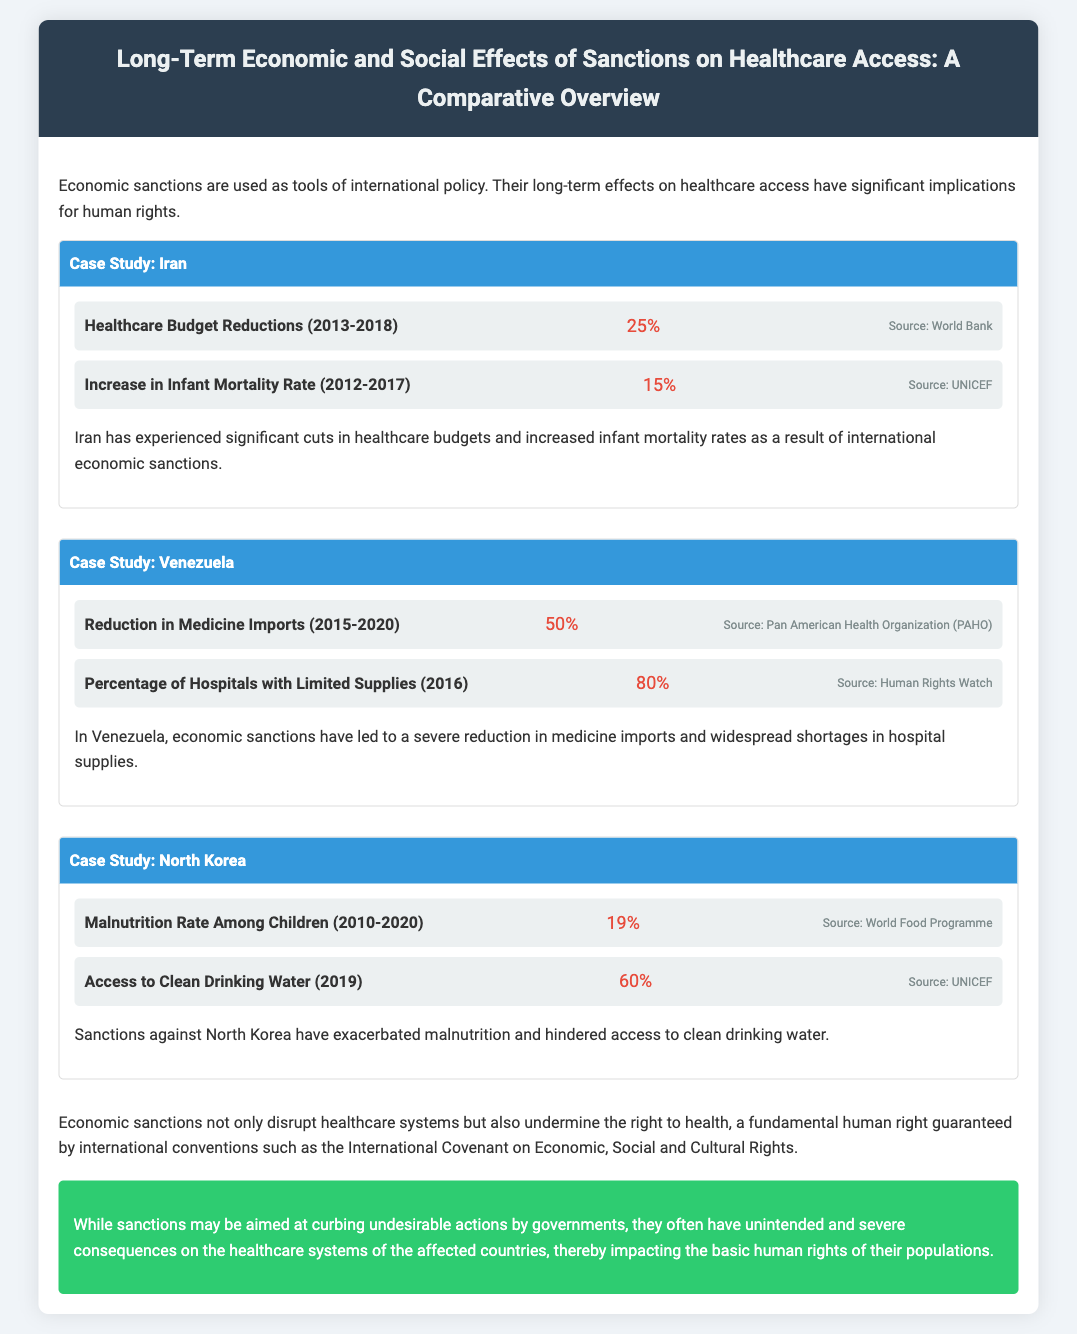What was the percentage reduction in Iran's healthcare budget from 2013 to 2018? The document states that the healthcare budget in Iran was reduced by 25% between 2013 and 2018.
Answer: 25% What is the increase in infant mortality rate in Iran from 2012 to 2017? According to the document, the infant mortality rate in Iran increased by 15% during this period.
Answer: 15% What percentage of hospitals in Venezuela had limited supplies in 2016? The document indicates that 80% of hospitals in Venezuela faced limited supplies in the year 2016.
Answer: 80% By what percentage did medicine imports reduce in Venezuela from 2015 to 2020? The document specifies a 50% reduction in medicine imports in Venezuela during this timeframe.
Answer: 50% What was the malnutrition rate among children in North Korea from 2010 to 2020? The document mentions a 19% malnutrition rate among children in North Korea over the specified period.
Answer: 19% What percentage of North Korea had access to clean drinking water in 2019? The document states that in 2019, 60% of North Korea's population had access to clean drinking water.
Answer: 60% What is a fundamental human right impacted by economic sanctions as mentioned in the document? The document highlights the right to health as a fundamental human right affected by economic sanctions.
Answer: Right to health What years does the case study for Iran cover? The document notes that the relevant years for Iran's case study are from 2013 to 2018.
Answer: 2013-2018 What is the source of the information indicating the increase in infant mortality in Iran? The document attributes the increase in infant mortality to UNICEF as the source.
Answer: UNICEF 